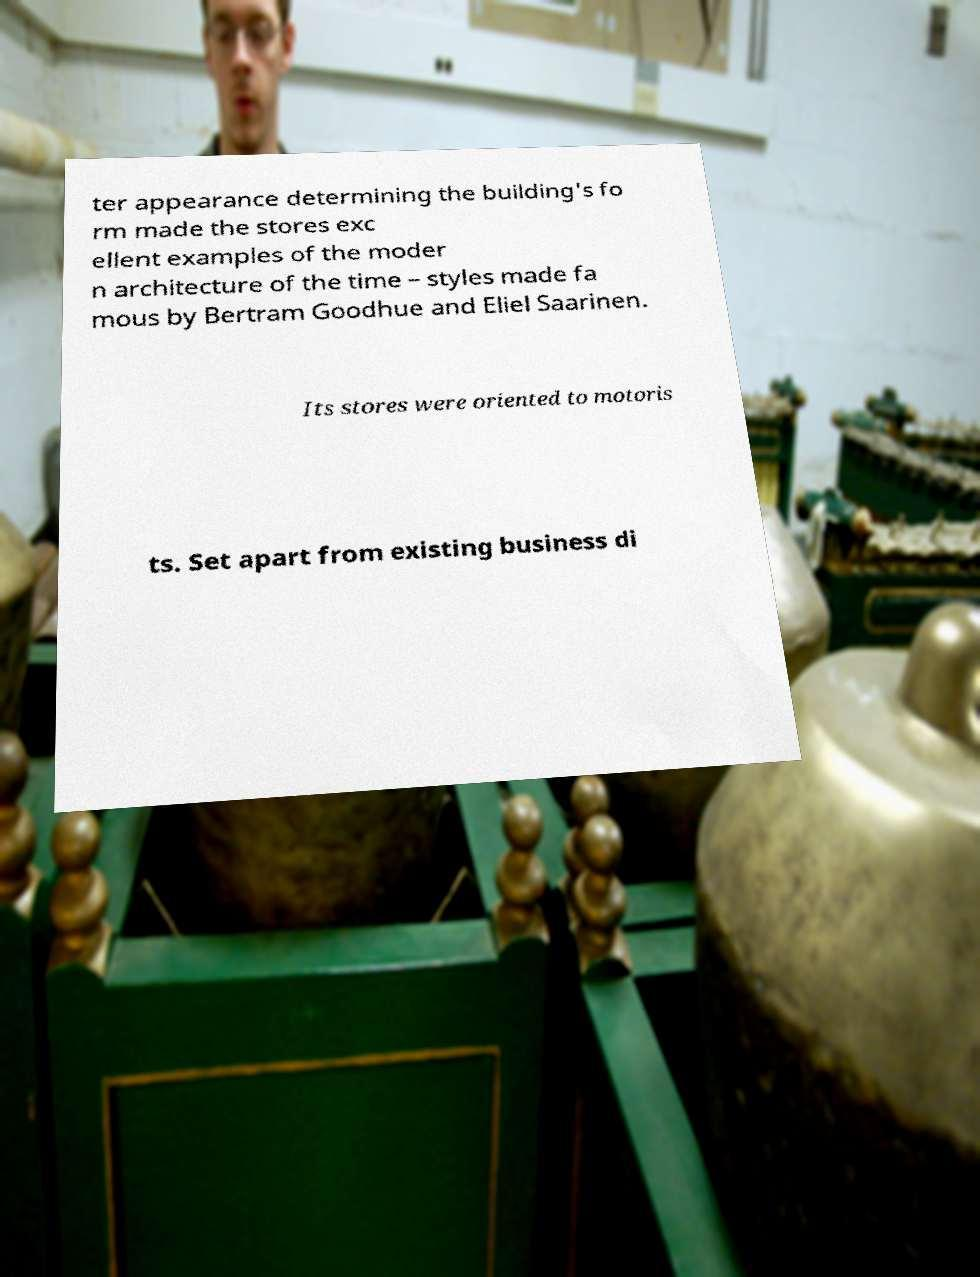Can you accurately transcribe the text from the provided image for me? ter appearance determining the building's fo rm made the stores exc ellent examples of the moder n architecture of the time – styles made fa mous by Bertram Goodhue and Eliel Saarinen. Its stores were oriented to motoris ts. Set apart from existing business di 